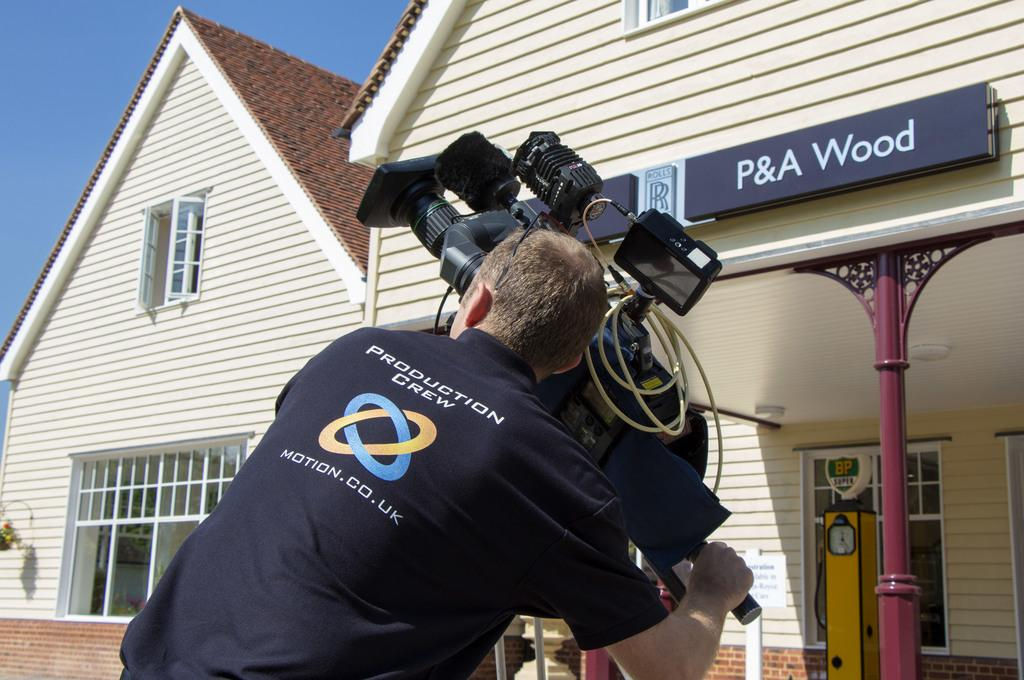Who is the main subject in the image? There is a man in the center of the image. What is the man holding in the image? The man is holding a camera. What can be seen in the background of the image? There is a building in the background of the image. What is written on the board on the wall of the building? The facts provided do not mention the content of the text on the board. How many balls is the man playing with in the image? There are no balls present in the image. 